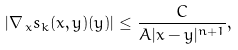Convert formula to latex. <formula><loc_0><loc_0><loc_500><loc_500>| \nabla _ { \, x } s _ { k } ( x , y ) ( y ) | \leq \frac { C } { A | x - y | ^ { n + 1 } } ,</formula> 